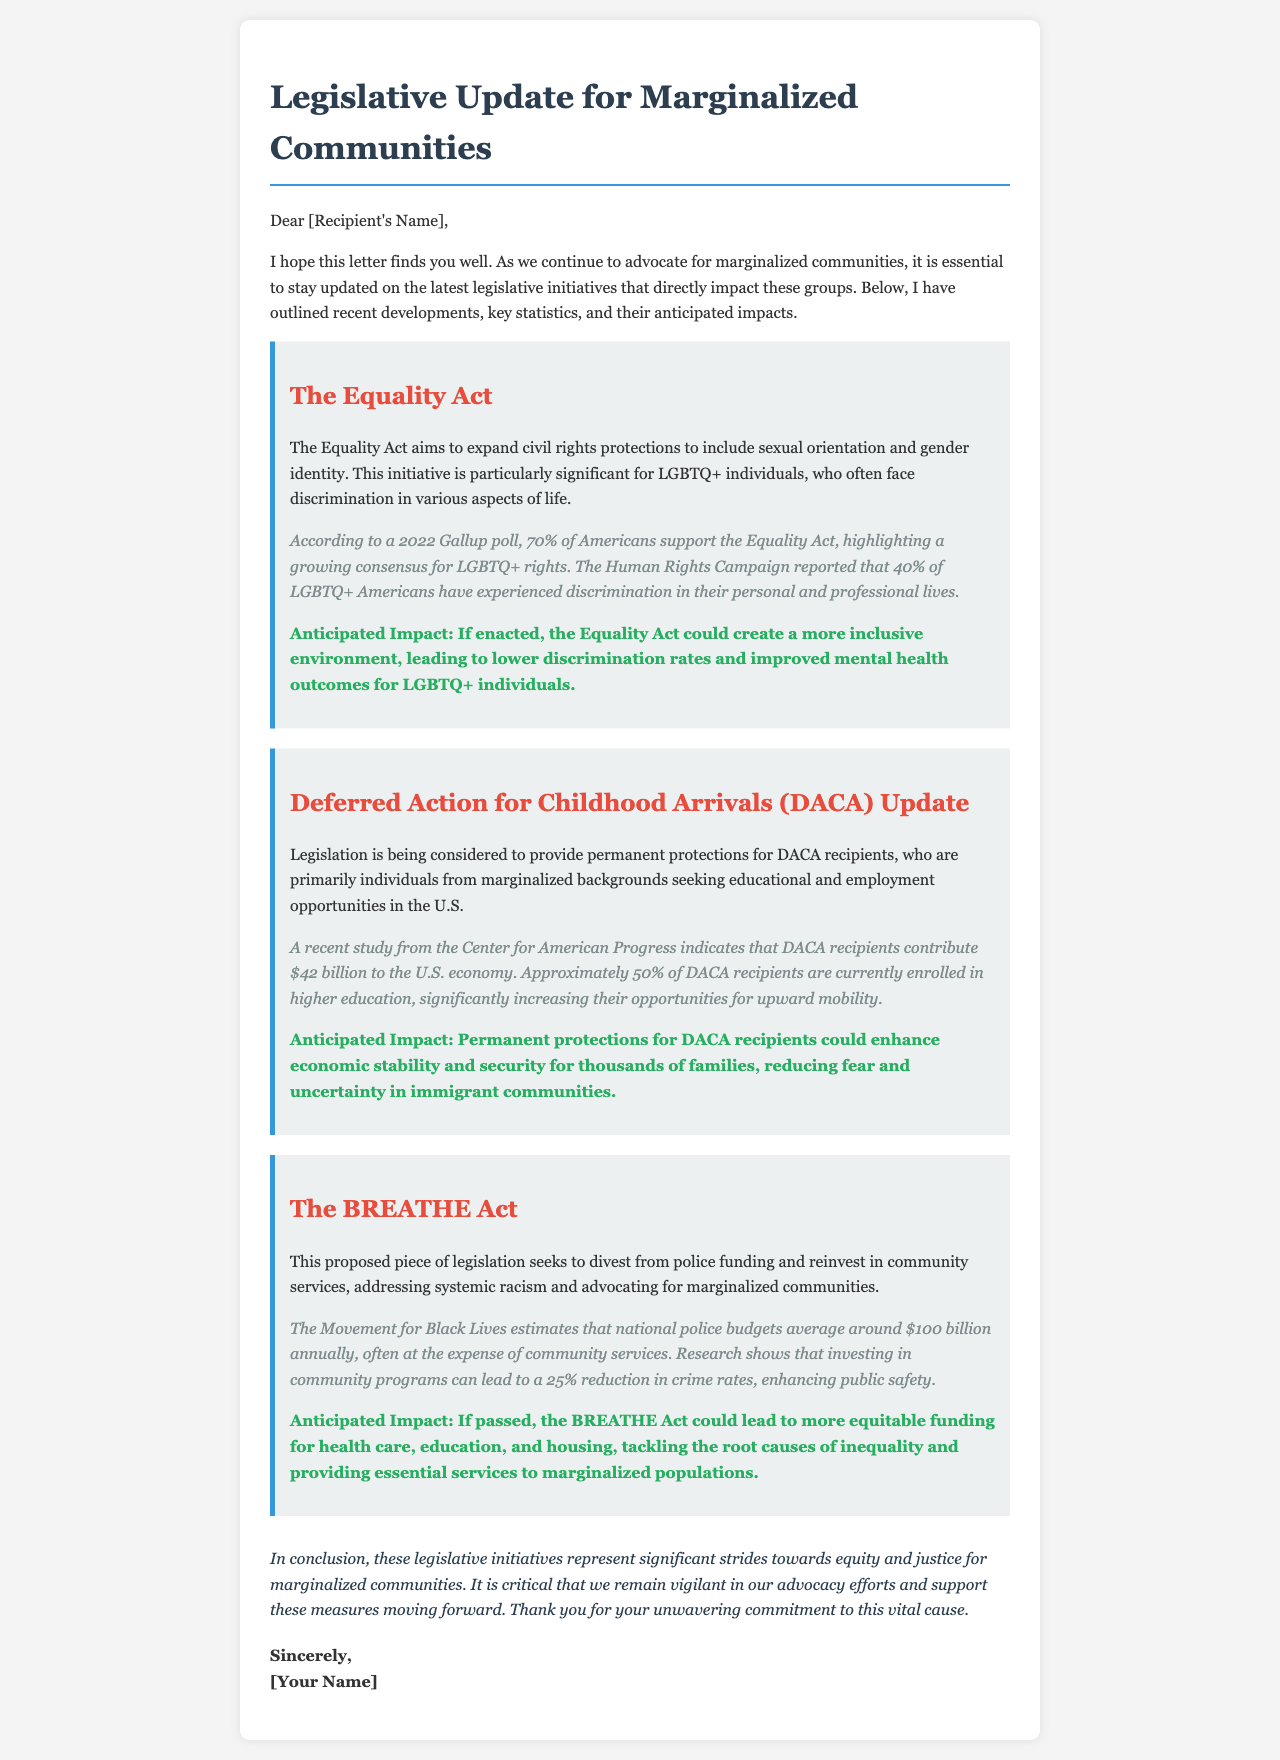What is the title of the document? The title is clearly stated at the top of the document, which highlights the main theme.
Answer: Legislative Update for Marginalized Communities Who is the first initiative mentioned in the document? The document contains several initiatives, and the first one is identified in its dedicated section.
Answer: The Equality Act What percentage of Americans support the Equality Act according to the document? The document provides a specific statistic regarding public opinion on the Equality Act.
Answer: 70% What is the anticipated impact of the BREATHE Act? The document details the expected outcomes of the BREATHE Act under its impact section.
Answer: More equitable funding for health care, education, and housing How much do DACA recipients contribute to the U.S. economy? The document includes a financial statistic relating to DACA recipients and their economic impact.
Answer: $42 billion What organization reported that 40% of LGBTQ+ Americans have experienced discrimination? The document cites a specific organization that provided this important statistic.
Answer: Human Rights Campaign What does DACA stand for? The document mentions DACA multiple times, and its full form can be derived from the context in which it is used.
Answer: Deferred Action for Childhood Arrivals What is the main goal of the Equality Act? The document outlines the purpose of the Equality Act in its description.
Answer: Expand civil rights protections to include sexual orientation and gender identity What color is used for the headings in the letter? The document's styling can be inferred to describe the color scheme applied to headings throughout the text.
Answer: #2c3e50 